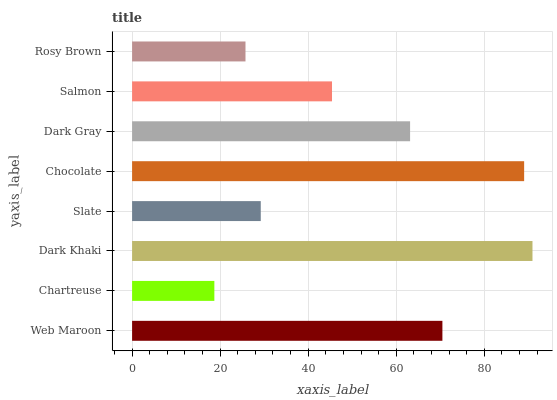Is Chartreuse the minimum?
Answer yes or no. Yes. Is Dark Khaki the maximum?
Answer yes or no. Yes. Is Dark Khaki the minimum?
Answer yes or no. No. Is Chartreuse the maximum?
Answer yes or no. No. Is Dark Khaki greater than Chartreuse?
Answer yes or no. Yes. Is Chartreuse less than Dark Khaki?
Answer yes or no. Yes. Is Chartreuse greater than Dark Khaki?
Answer yes or no. No. Is Dark Khaki less than Chartreuse?
Answer yes or no. No. Is Dark Gray the high median?
Answer yes or no. Yes. Is Salmon the low median?
Answer yes or no. Yes. Is Dark Khaki the high median?
Answer yes or no. No. Is Chocolate the low median?
Answer yes or no. No. 